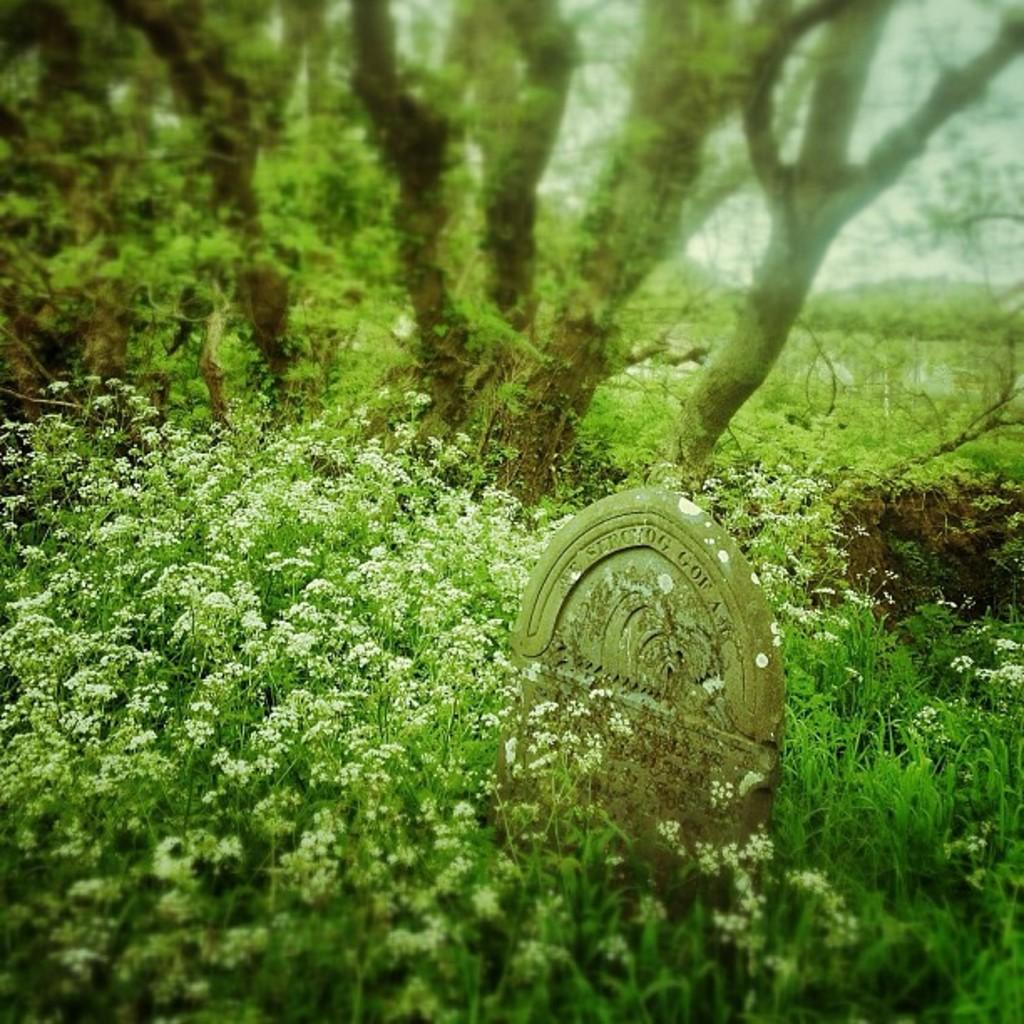What type of living organisms can be seen in the image? Plants can be seen in the image. What is the primary object in the foreground of the image? There is a grave stone in the image. What can be seen in the background of the image? Trees are visible in the background of the image. Can any geographical features be identified in the background? Yes, there are hills in the background of the image, although they are not clearly visible. What type of metal can be seen in the alley behind the grave stone? There is no alley present in the image, and therefore no metal can be seen in the alley. 